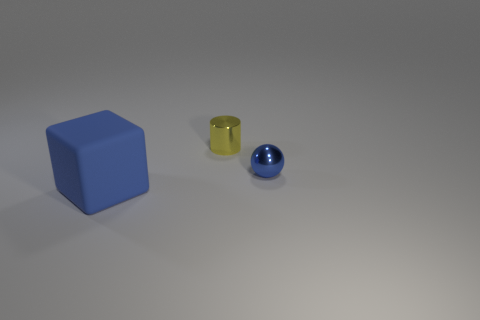Are there any other things of the same color as the big object?
Your answer should be compact. Yes. There is a thing that is both behind the big blue object and in front of the small yellow metallic cylinder; what is its shape?
Your response must be concise. Sphere. Is the number of large matte blocks behind the blue sphere the same as the number of yellow objects to the right of the rubber thing?
Your response must be concise. No. What number of cylinders are either blue metal things or yellow things?
Your answer should be very brief. 1. What number of large red things have the same material as the yellow cylinder?
Your response must be concise. 0. The small object that is the same color as the cube is what shape?
Your response must be concise. Sphere. What is the object that is both in front of the yellow shiny object and left of the blue metallic ball made of?
Your answer should be compact. Rubber. What shape is the object on the left side of the yellow metallic cylinder?
Provide a short and direct response. Cube. The metal thing on the left side of the metal thing that is on the right side of the yellow shiny cylinder is what shape?
Offer a very short reply. Cylinder. Are there any other small objects of the same shape as the blue matte object?
Offer a very short reply. No. 